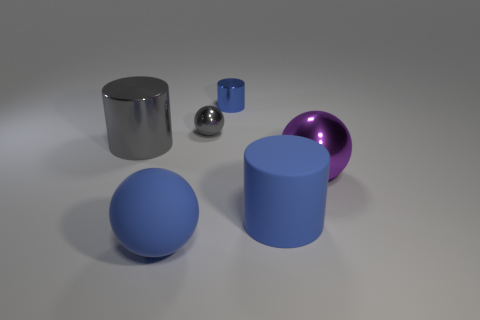Is the number of large rubber things greater than the number of blue things?
Ensure brevity in your answer.  No. How many blocks are large purple metallic objects or big gray things?
Make the answer very short. 0. What color is the big rubber cylinder?
Give a very brief answer. Blue. Does the blue sphere on the left side of the tiny metallic cylinder have the same size as the metallic thing that is right of the large blue rubber cylinder?
Provide a short and direct response. Yes. Are there fewer small metallic things than big blue cylinders?
Ensure brevity in your answer.  No. What number of blue objects are in front of the big blue matte cylinder?
Your response must be concise. 1. What is the material of the big purple object?
Your answer should be very brief. Metal. Is the small cylinder the same color as the rubber cylinder?
Your answer should be very brief. Yes. Is the number of balls that are to the right of the large metallic ball less than the number of tiny purple matte things?
Offer a terse response. No. There is a big rubber object that is behind the big matte ball; what color is it?
Give a very brief answer. Blue. 